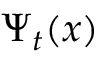<formula> <loc_0><loc_0><loc_500><loc_500>\Psi _ { t } ( x )</formula> 